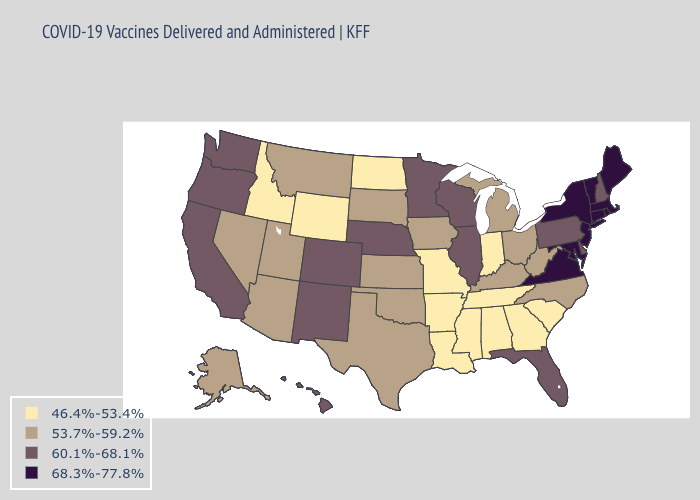Does Kentucky have a lower value than Kansas?
Be succinct. No. Among the states that border Iowa , which have the highest value?
Concise answer only. Illinois, Minnesota, Nebraska, Wisconsin. Name the states that have a value in the range 46.4%-53.4%?
Be succinct. Alabama, Arkansas, Georgia, Idaho, Indiana, Louisiana, Mississippi, Missouri, North Dakota, South Carolina, Tennessee, Wyoming. What is the value of Connecticut?
Give a very brief answer. 68.3%-77.8%. What is the value of Mississippi?
Concise answer only. 46.4%-53.4%. Is the legend a continuous bar?
Keep it brief. No. Name the states that have a value in the range 60.1%-68.1%?
Answer briefly. California, Colorado, Delaware, Florida, Hawaii, Illinois, Minnesota, Nebraska, New Hampshire, New Mexico, Oregon, Pennsylvania, Washington, Wisconsin. What is the lowest value in the West?
Quick response, please. 46.4%-53.4%. Name the states that have a value in the range 46.4%-53.4%?
Give a very brief answer. Alabama, Arkansas, Georgia, Idaho, Indiana, Louisiana, Mississippi, Missouri, North Dakota, South Carolina, Tennessee, Wyoming. What is the value of Virginia?
Concise answer only. 68.3%-77.8%. Does Florida have the highest value in the South?
Answer briefly. No. How many symbols are there in the legend?
Answer briefly. 4. Name the states that have a value in the range 46.4%-53.4%?
Quick response, please. Alabama, Arkansas, Georgia, Idaho, Indiana, Louisiana, Mississippi, Missouri, North Dakota, South Carolina, Tennessee, Wyoming. Which states hav the highest value in the South?
Give a very brief answer. Maryland, Virginia. What is the value of Indiana?
Write a very short answer. 46.4%-53.4%. 